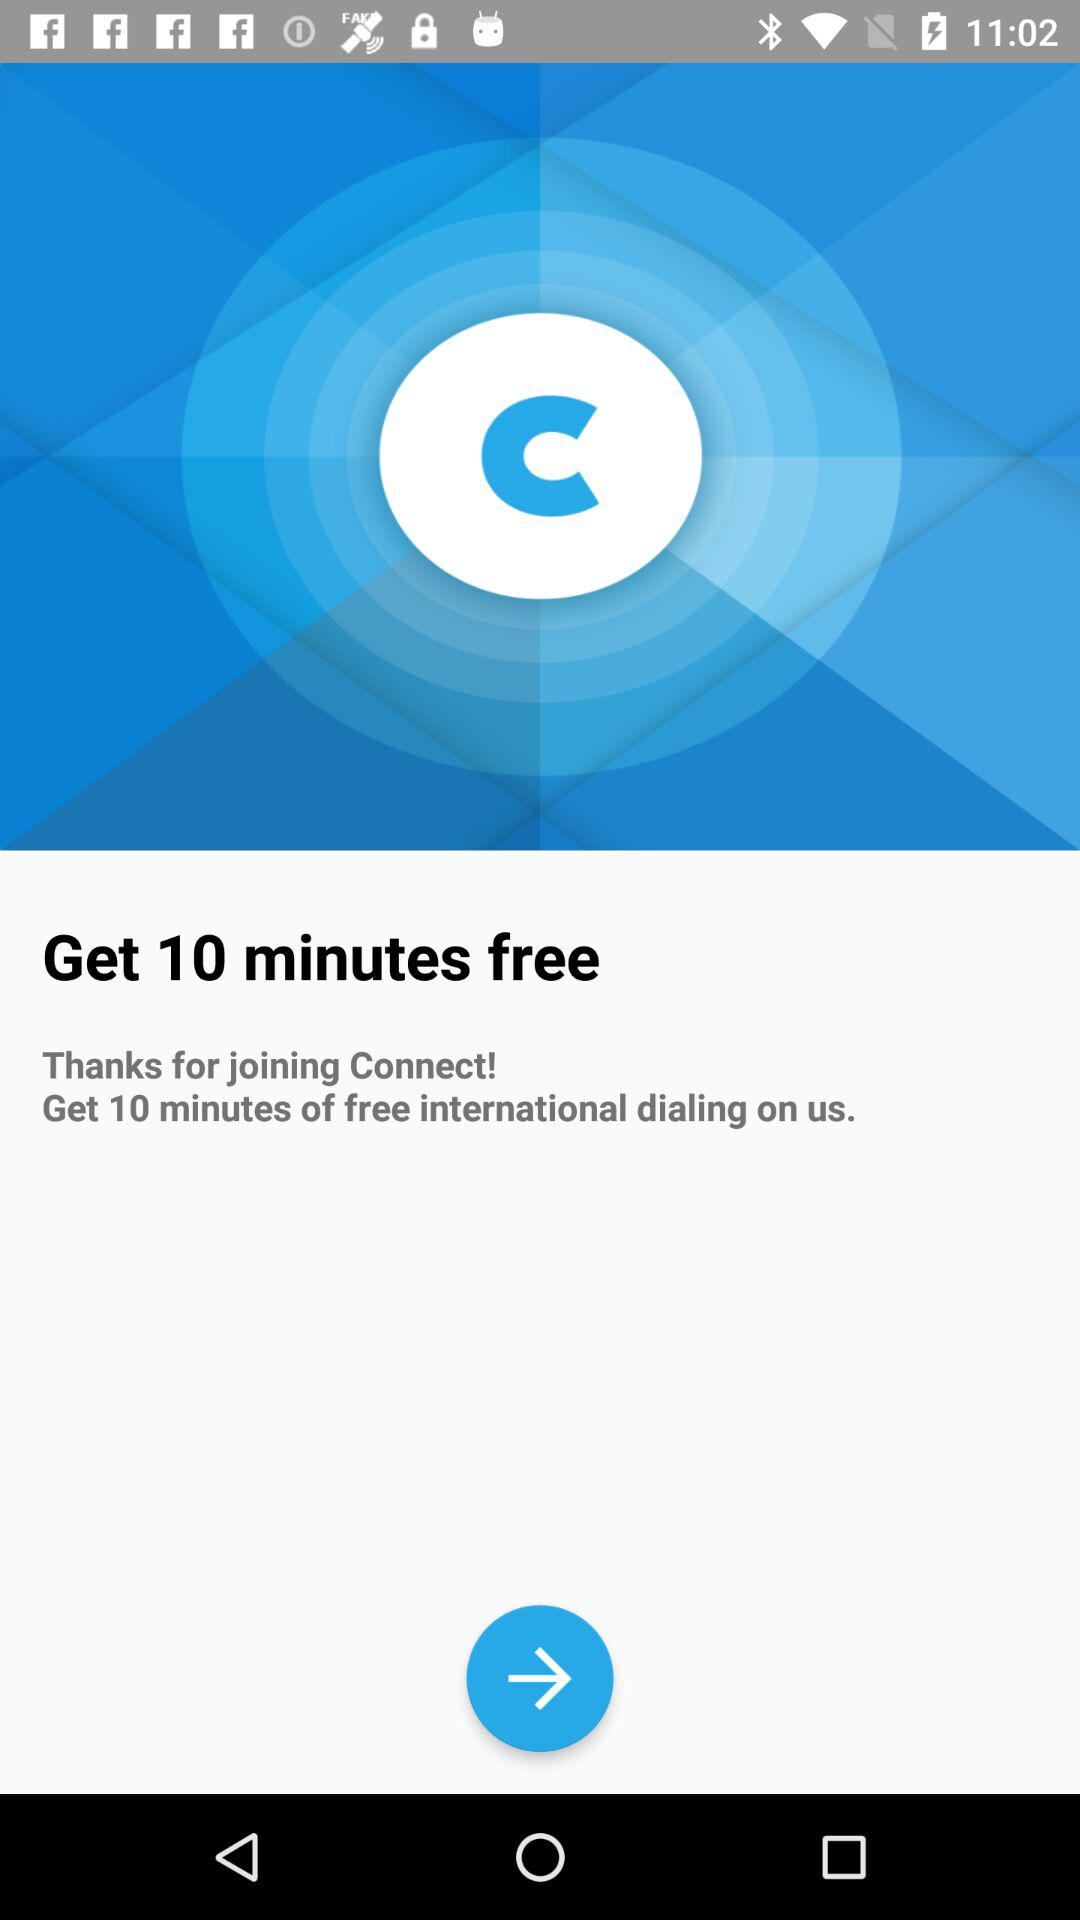How many minutes of free international dialing does Connect offer?
Answer the question using a single word or phrase. 10 